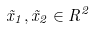Convert formula to latex. <formula><loc_0><loc_0><loc_500><loc_500>\vec { x } _ { 1 } , \vec { x } _ { 2 } \in R ^ { 2 }</formula> 